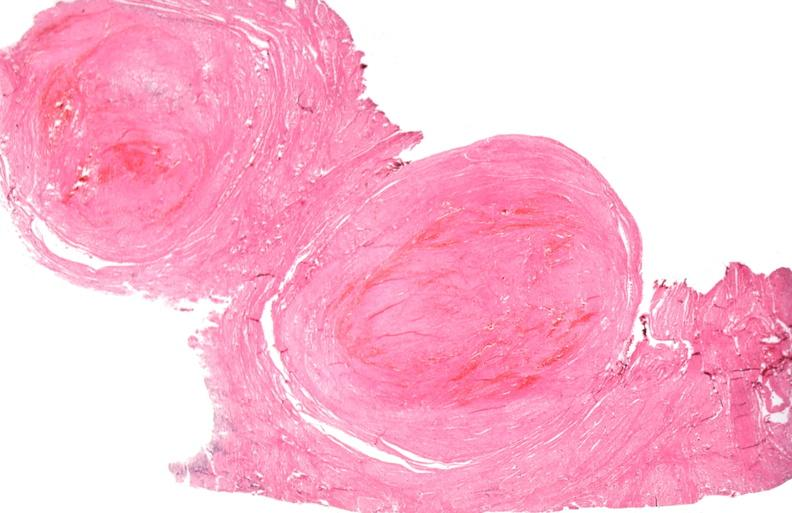what is present?
Answer the question using a single word or phrase. Female reproductive 